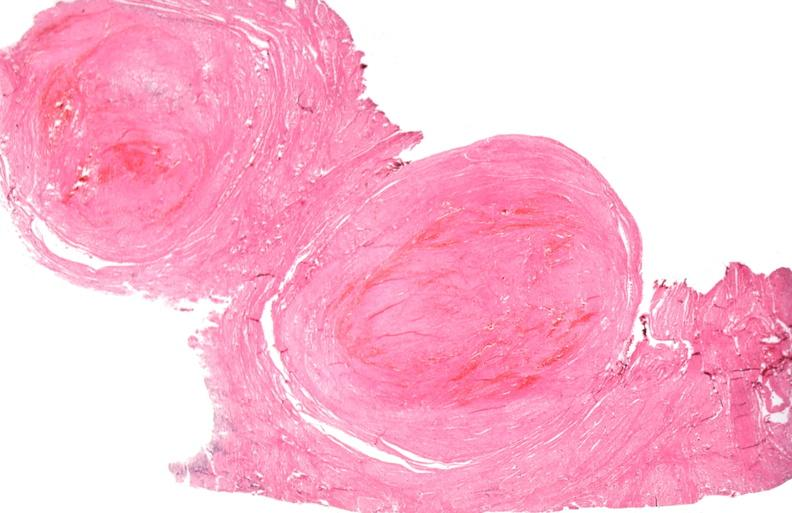what is present?
Answer the question using a single word or phrase. Female reproductive 